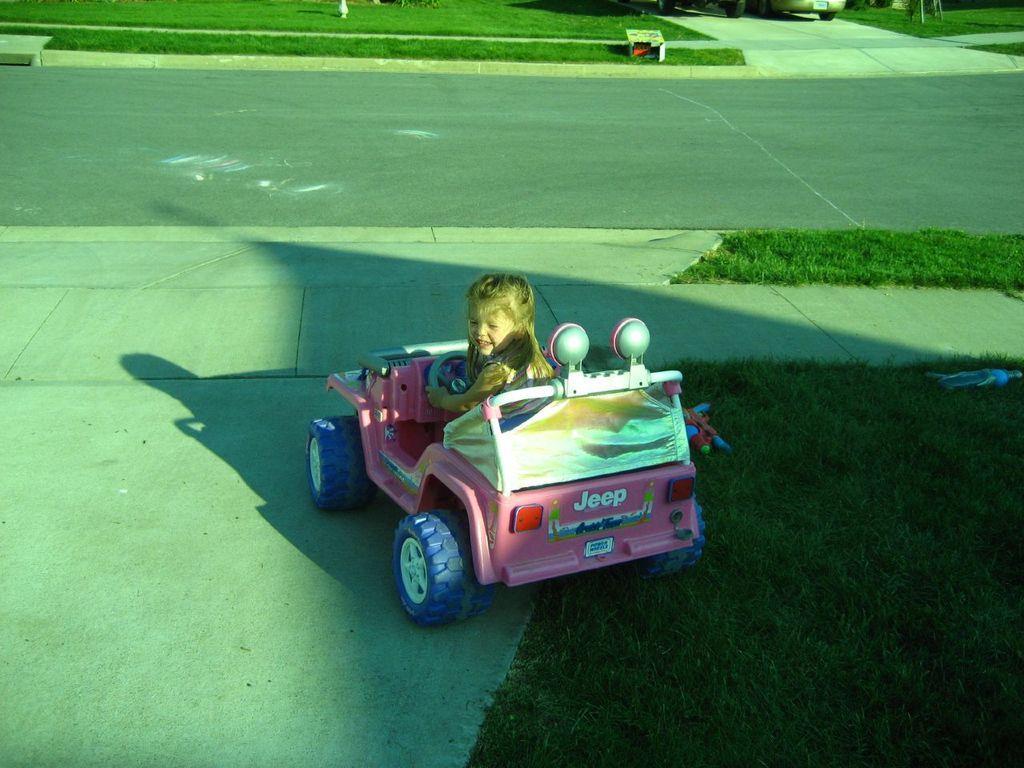Describe this image in one or two sentences. In this picture there is a small girl sitting in the pink color car toy. Behind there is a grass lawn and small road lane. 